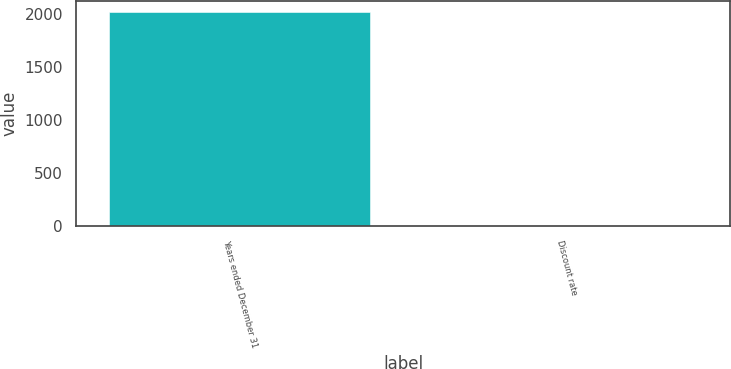Convert chart to OTSL. <chart><loc_0><loc_0><loc_500><loc_500><bar_chart><fcel>Years ended December 31<fcel>Discount rate<nl><fcel>2018<fcel>3.65<nl></chart> 